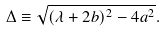Convert formula to latex. <formula><loc_0><loc_0><loc_500><loc_500>\Delta \equiv \sqrt { ( \lambda + 2 b ) ^ { 2 } - 4 a ^ { 2 } } .</formula> 